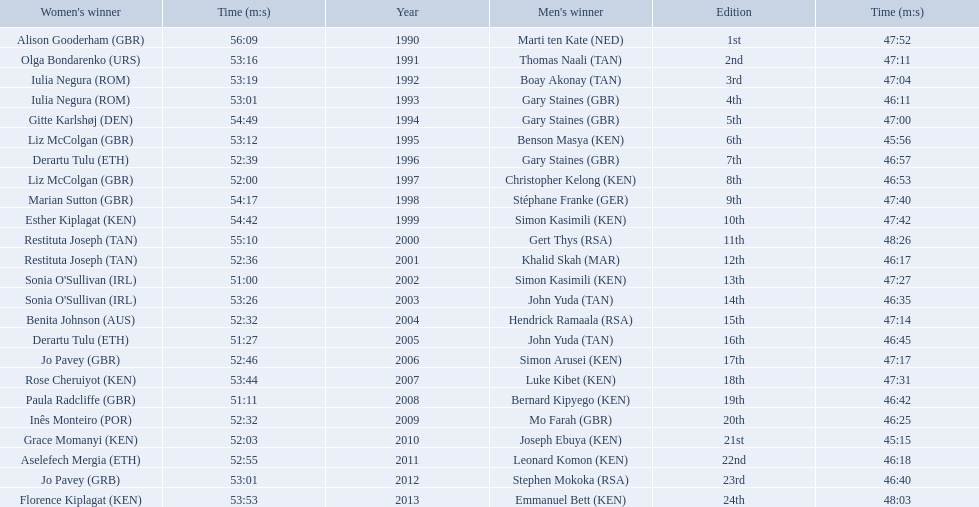Who were all the runners' times between 1990 and 2013? 47:52, 56:09, 47:11, 53:16, 47:04, 53:19, 46:11, 53:01, 47:00, 54:49, 45:56, 53:12, 46:57, 52:39, 46:53, 52:00, 47:40, 54:17, 47:42, 54:42, 48:26, 55:10, 46:17, 52:36, 47:27, 51:00, 46:35, 53:26, 47:14, 52:32, 46:45, 51:27, 47:17, 52:46, 47:31, 53:44, 46:42, 51:11, 46:25, 52:32, 45:15, 52:03, 46:18, 52:55, 46:40, 53:01, 48:03, 53:53. Which was the fastest time? 45:15. Who ran that time? Joseph Ebuya (KEN). 